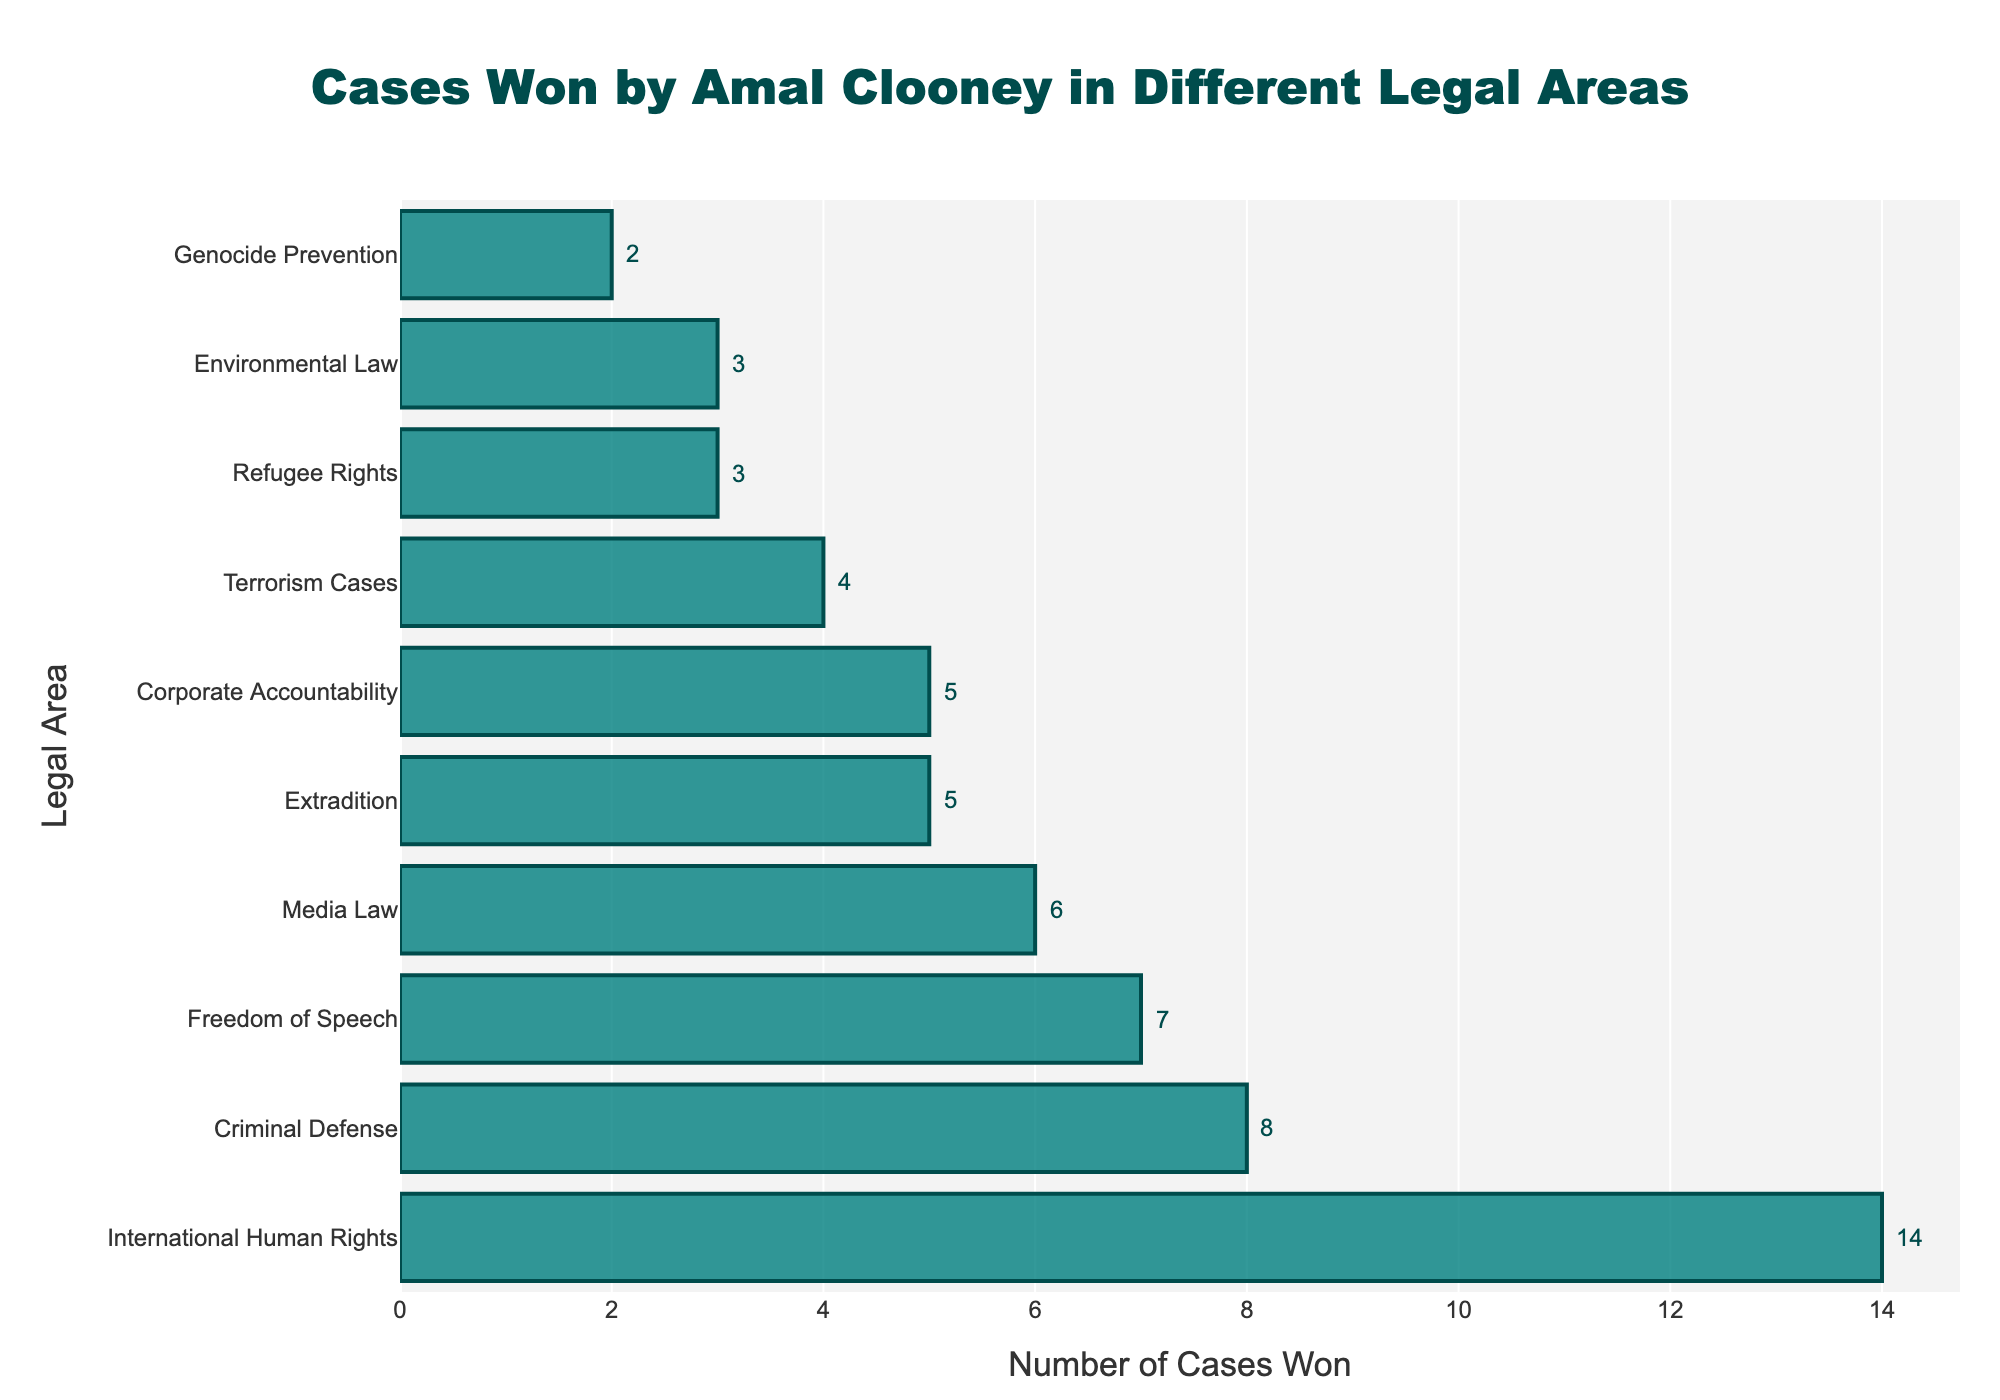What is the total number of cases won in International Human Rights and Criminal Defense combined? Add the number of cases won in International Human Rights (14) to those in Criminal Defense (8). So, 14 + 8 = 22.
Answer: 22 Which legal area has the least number of cases won? Genocide Prevention has the least number of cases won with 2 cases.
Answer: Genocide Prevention Are there more cases won in Media Law or Extradition? Compare the number of cases won in Media Law (6) to Extradition (5). Media Law has one more case won than Extradition.
Answer: Media Law How many more cases has Amal Clooney won in Freedom of Speech compared to Terrorism Cases? Subtract the number of cases won in Terrorism Cases (4) from those in Freedom of Speech (7). So, 7 - 4 = 3.
Answer: 3 What is the average number of cases won in Corporate Accountability, Environmental Law, and Refugee Rights? Sum the number of cases won in Corporate Accountability (5), Environmental Law (3), and Refugee Rights (3), which is 5 + 3 + 3 = 11. Then, divide by the number of legal areas (3), so 11 / 3 = 3.67.
Answer: 3.67 Which legal area has the second highest number of cases won? The legal area with the second highest number of cases won is Criminal Defense, with 8 cases.
Answer: Criminal Defense How does the height of the bar for International Human Rights compare to the bar for Genocide Prevention? The bar for International Human Rights (14 cases) is much taller than the bar for Genocide Prevention (2 cases).
Answer: Much taller What is the sum of cases won in the three areas with the fewest cases? The areas with the fewest cases are Genocide Prevention (2), Refugee Rights (3), and Environmental Law (3). So, 2 + 3 + 3 = 8.
Answer: 8 Which is greater: the difference between cases won in International Human Rights and Corporate Accountability, or the sum of cases won in Media Law and Extradition? First, find the difference between International Human Rights (14) and Corporate Accountability (5), which is 14 - 5 = 9. Then, find the sum of cases won in Media Law (6) and Extradition (5), which is 6 + 5 = 11. Comparing 9 and 11, the sum (11) is greater.
Answer: Sum (11) What percentage of the total cases won does Terrorism Cases represent? First, find the total number of cases won: 14 (International Human Rights) + 8 (Criminal Defense) + 6 (Media Law) + 5 (Extradition) + 4 (Terrorism Cases) + 7 (Freedom of Speech) + 3 (Refugee Rights) + 2 (Genocide Prevention) + 3 (Environmental Law) + 5 (Corporate Accountability) = 57. Then, calculate (Terrorism Cases / Total Cases) * 100 = (4 / 57) * 100 ≈ 7.02%.
Answer: 7.02% 